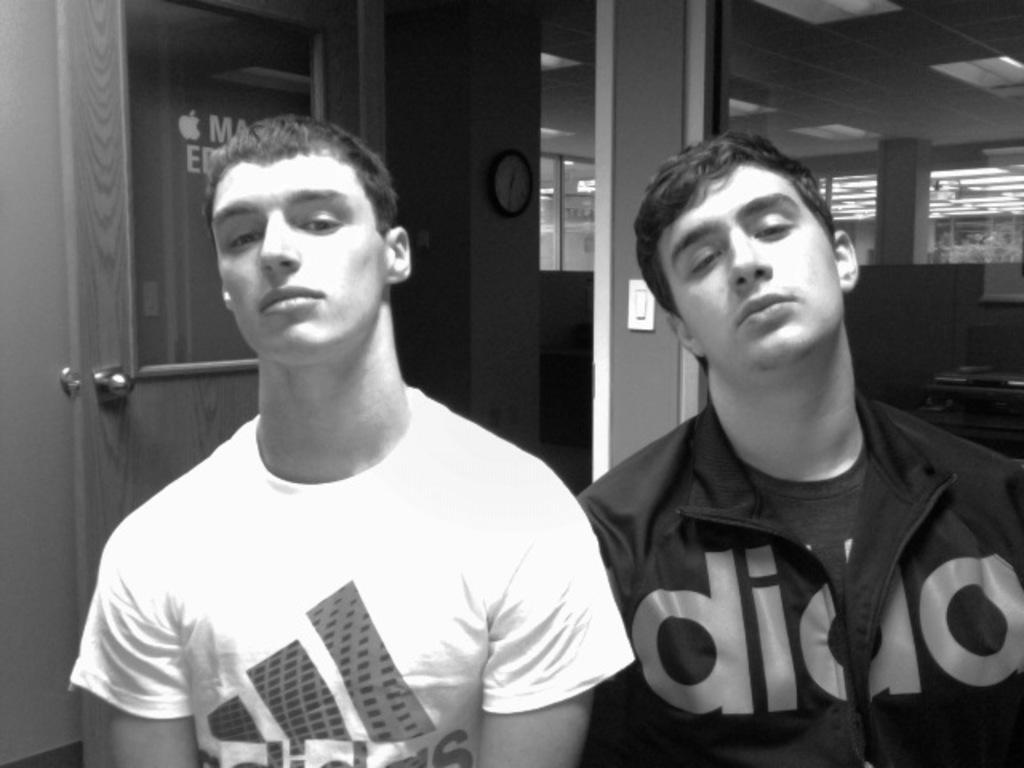Could you give a brief overview of what you see in this image? This picture might be taken inside the room. In this image, in the middle and on the right side, we can see two men. In the background, there is a door and a wall, clock which is attached to a wall, switch board. On the right side, there is a table. On that table, we can see laptop. In the background, there is a pillar. On top there is a roof with few lights. 